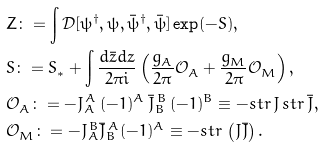Convert formula to latex. <formula><loc_0><loc_0><loc_500><loc_500>& Z \colon = \int \mathcal { D } [ \psi ^ { \dag } , \psi , \bar { \psi } ^ { \dag } , \bar { \psi } ] \exp ( - S ) , \\ & S \colon = S ^ { \ } _ { * } + \int \frac { d \bar { z } d z } { 2 \pi { i } } \left ( \frac { g ^ { \ } _ { A } } { 2 \pi } \mathcal { O } ^ { \ } _ { A } + \frac { g ^ { \ } _ { M } } { 2 \pi } \mathcal { O } ^ { \ } _ { M } \right ) , \\ & \mathcal { O } ^ { \ } _ { A } \colon = - J ^ { \, A } _ { A } \, ( - 1 ) ^ { A } \, \bar { J } ^ { \, B } _ { B } \, ( - 1 ) ^ { B } \equiv - s t r \, J \, s t r \, \bar { J } , \\ & \mathcal { O } ^ { \ } _ { M } \colon = - J ^ { \, B } _ { A } \bar { J } ^ { \, A } _ { B } ( - 1 ) ^ { A } \equiv - s t r \, \left ( J \bar { J } \right ) .</formula> 